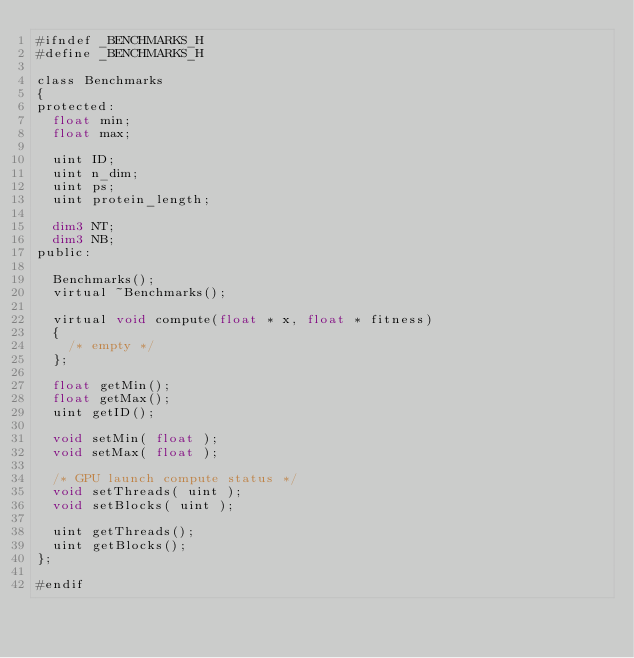Convert code to text. <code><loc_0><loc_0><loc_500><loc_500><_Cuda_>#ifndef _BENCHMARKS_H
#define _BENCHMARKS_H

class Benchmarks
{
protected:
  float min;
  float max;

  uint ID;
  uint n_dim;
  uint ps;
  uint protein_length;

  dim3 NT;
  dim3 NB;
public:

  Benchmarks();
  virtual ~Benchmarks();

  virtual void compute(float * x, float * fitness)
  {
    /* empty */
  };

  float getMin();
  float getMax();
  uint getID();

  void setMin( float );
  void setMax( float );

  /* GPU launch compute status */
  void setThreads( uint );
  void setBlocks( uint );

  uint getThreads();
  uint getBlocks();
};

#endif
</code> 